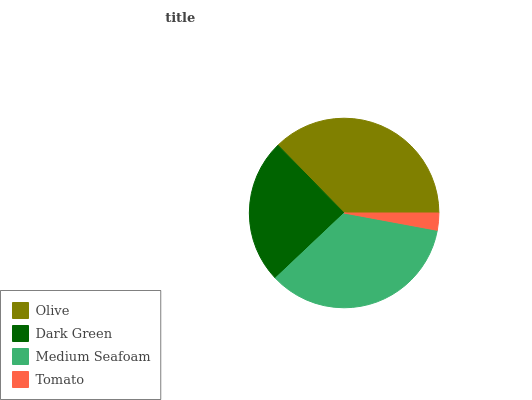Is Tomato the minimum?
Answer yes or no. Yes. Is Olive the maximum?
Answer yes or no. Yes. Is Dark Green the minimum?
Answer yes or no. No. Is Dark Green the maximum?
Answer yes or no. No. Is Olive greater than Dark Green?
Answer yes or no. Yes. Is Dark Green less than Olive?
Answer yes or no. Yes. Is Dark Green greater than Olive?
Answer yes or no. No. Is Olive less than Dark Green?
Answer yes or no. No. Is Medium Seafoam the high median?
Answer yes or no. Yes. Is Dark Green the low median?
Answer yes or no. Yes. Is Tomato the high median?
Answer yes or no. No. Is Tomato the low median?
Answer yes or no. No. 